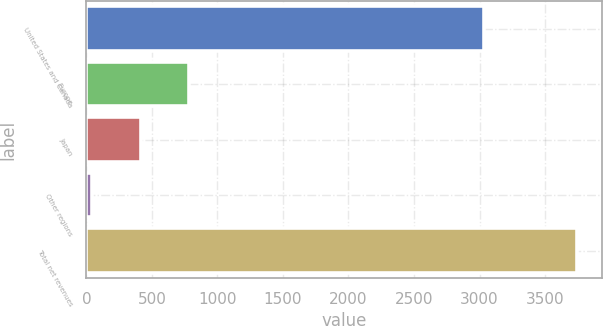Convert chart to OTSL. <chart><loc_0><loc_0><loc_500><loc_500><bar_chart><fcel>United States and Canada<fcel>Europe<fcel>Japan<fcel>Other regions<fcel>Total net revenues<nl><fcel>3032.3<fcel>782.86<fcel>412.43<fcel>42<fcel>3746.3<nl></chart> 